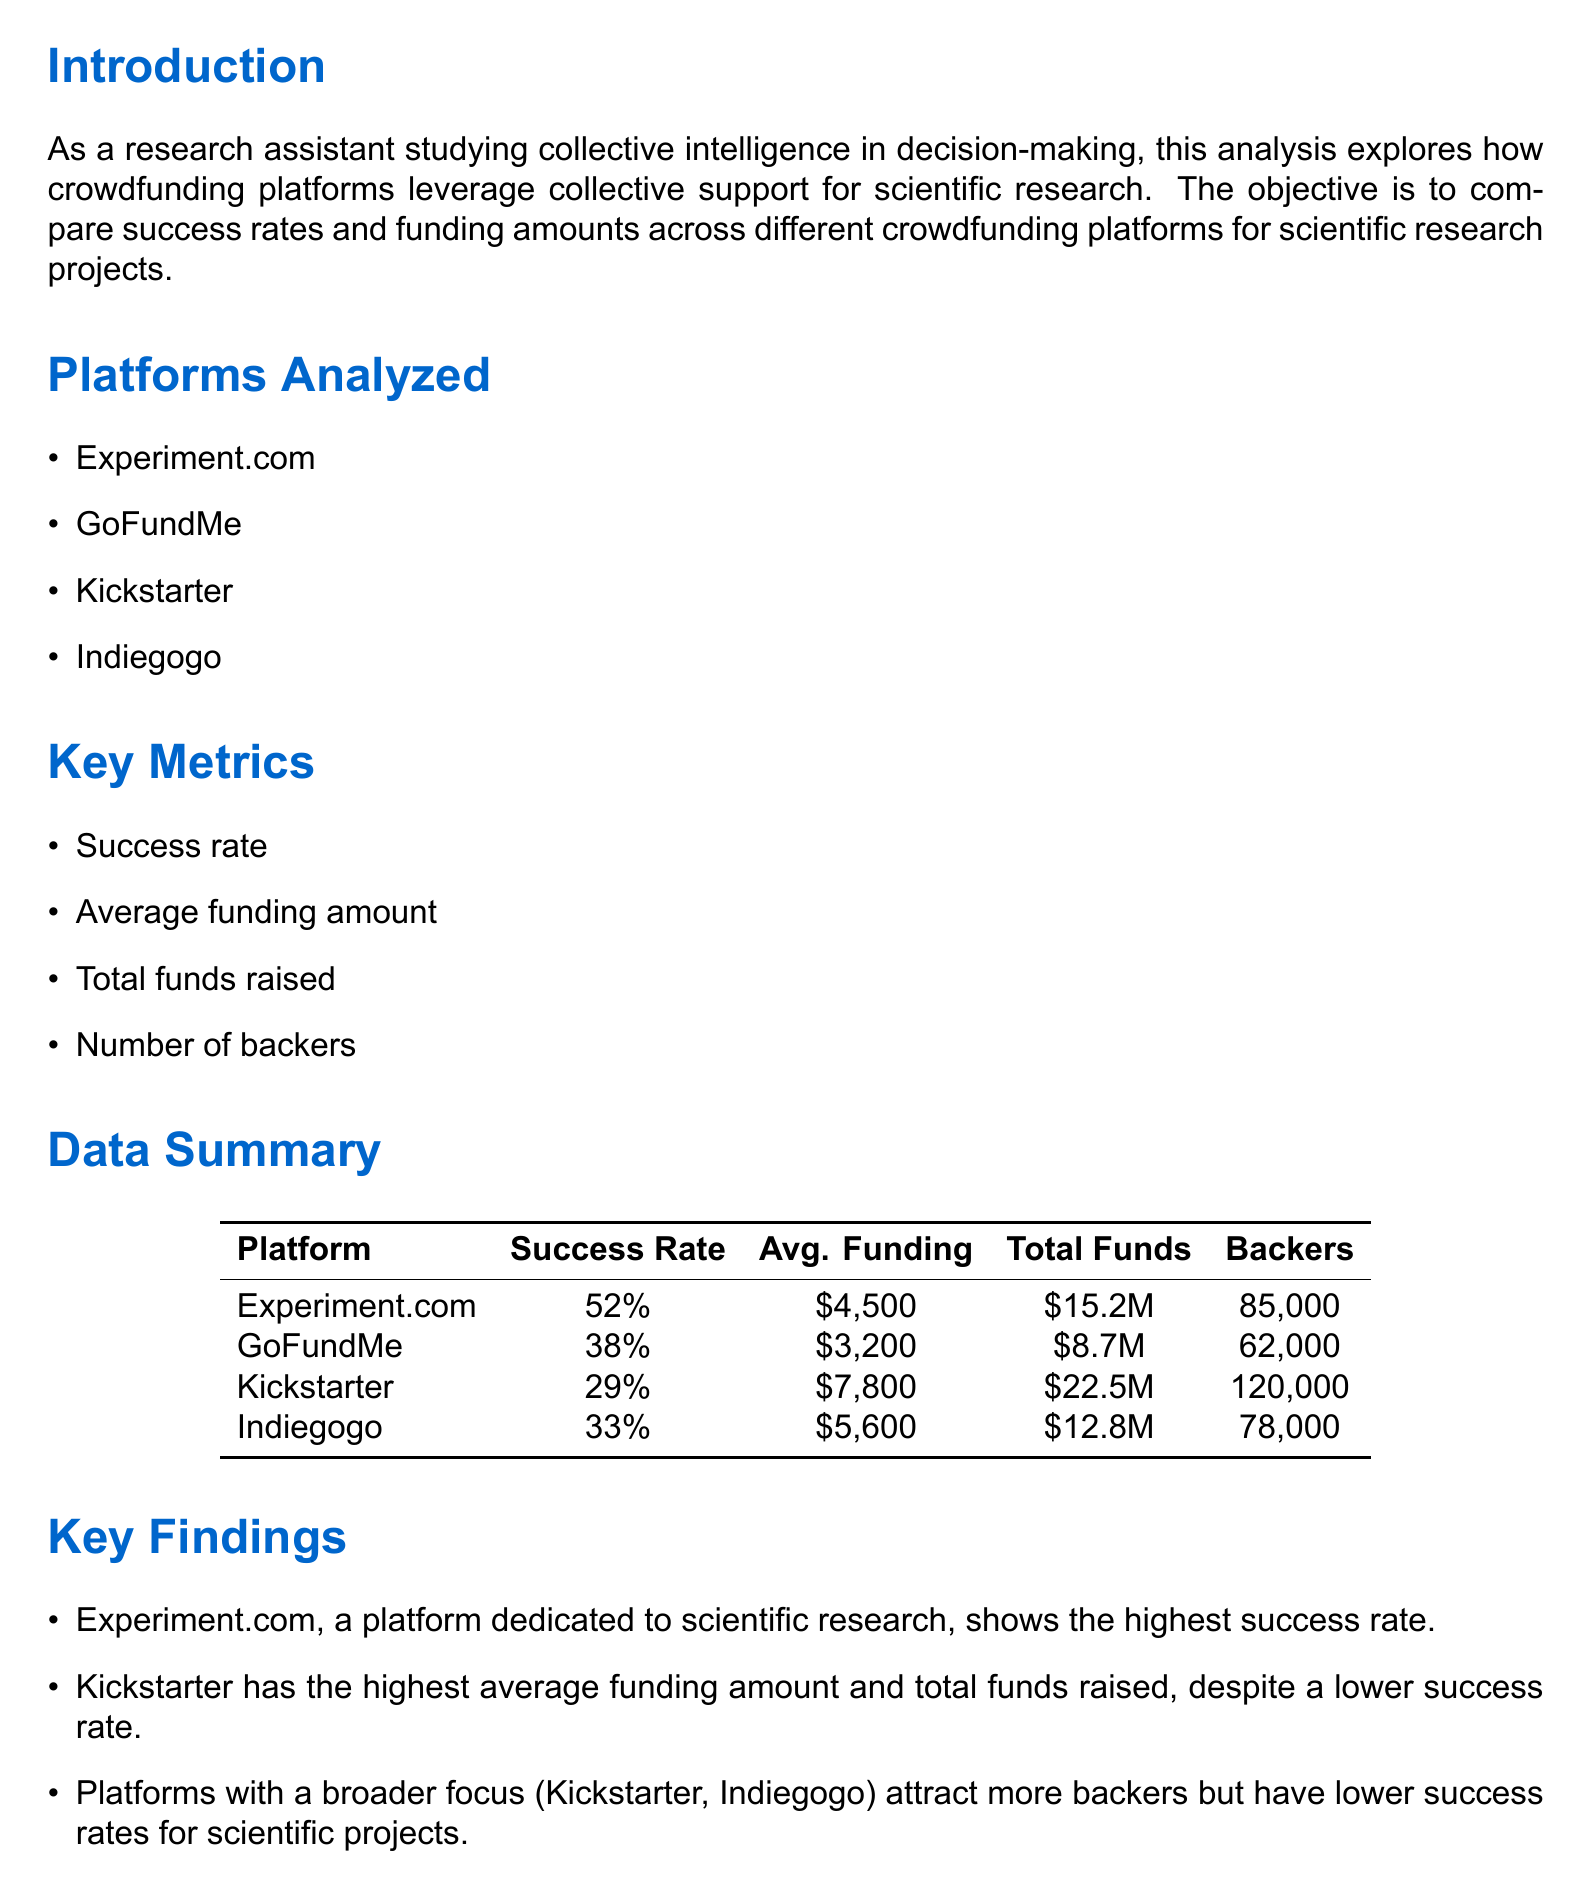What is the success rate of Experiment.com? The success rate of Experiment.com is explicitly listed in the data summary section of the document.
Answer: 52% What is the average funding amount on Kickstarter? The average funding amount for Kickstarter is provided in the data summary, allowing for quick retrieval of this metric.
Answer: $7,800 How many total funds were raised by GoFundMe? The document specifies the total funds raised by GoFundMe, making it a straightforward retrieval of information.
Answer: $8.7 million Which platform has the highest number of backers? The platform with the highest number of backers is mentioned in the data summary, facilitating a direct answer based on the information provided.
Answer: Kickstarter What is a key finding about Experiment.com? The document lists key findings, and one specific finding about Experiment.com can be easily extracted from it.
Answer: Highest success rate How do broader platforms compare in terms of success rates? This question requires reasoning across multiple findings in the document to draw a conclusion about broader platforms' performance.
Answer: Lower success rates What implication relates to funding scientific research effectively? The implications section discusses specialized platforms and their effectiveness, allowing for a concise answer based on that information.
Answer: Specialized platforms may be more effective How does collective intelligence vary in crowdfunding? The implications section notes a relationship between collective intelligence and platform specialization, prompting a deeper understanding of the document's themes.
Answer: Varies based on platform specialization and backer demographics What is the title of the document? The title is presented prominently at the beginning of the document, indicating concise retrieval of this information.
Answer: Financial Analysis of Crowdfunding Campaigns for Scientific Research Projects 